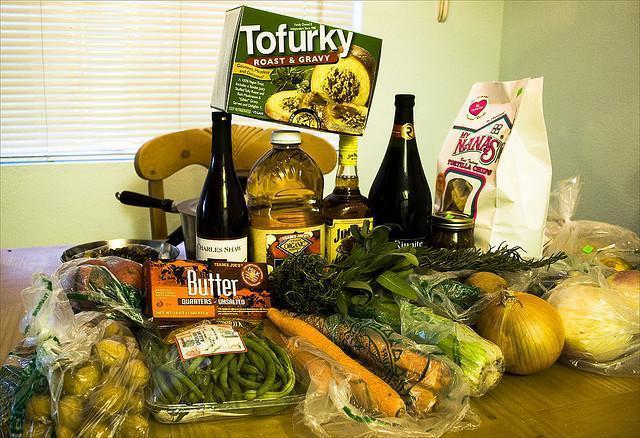How many carrots are there?
Give a very brief answer. 2. How many bottles are in the photo?
Give a very brief answer. 4. 